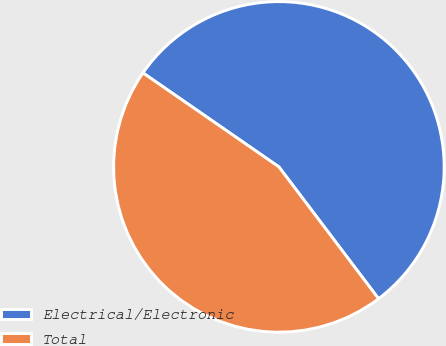<chart> <loc_0><loc_0><loc_500><loc_500><pie_chart><fcel>Electrical/Electronic<fcel>Total<nl><fcel>55.07%<fcel>44.93%<nl></chart> 